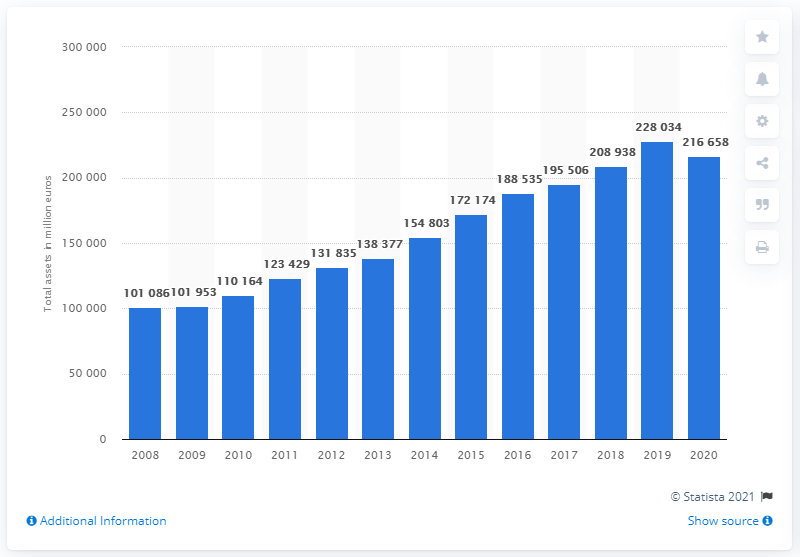Point out several critical features in this image. In the fiscal year of 2020, BMW Group's balance sheet total was 216,658. In the year 2008, BMW Group experienced its last fiscal year. In the year 2020, the BMW Group had a balance sheet total of approximately 217 billion euros. 